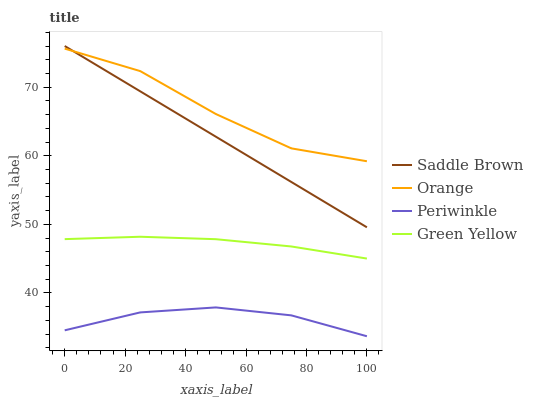Does Periwinkle have the minimum area under the curve?
Answer yes or no. Yes. Does Orange have the maximum area under the curve?
Answer yes or no. Yes. Does Green Yellow have the minimum area under the curve?
Answer yes or no. No. Does Green Yellow have the maximum area under the curve?
Answer yes or no. No. Is Saddle Brown the smoothest?
Answer yes or no. Yes. Is Orange the roughest?
Answer yes or no. Yes. Is Green Yellow the smoothest?
Answer yes or no. No. Is Green Yellow the roughest?
Answer yes or no. No. Does Periwinkle have the lowest value?
Answer yes or no. Yes. Does Green Yellow have the lowest value?
Answer yes or no. No. Does Saddle Brown have the highest value?
Answer yes or no. Yes. Does Green Yellow have the highest value?
Answer yes or no. No. Is Green Yellow less than Orange?
Answer yes or no. Yes. Is Saddle Brown greater than Green Yellow?
Answer yes or no. Yes. Does Orange intersect Saddle Brown?
Answer yes or no. Yes. Is Orange less than Saddle Brown?
Answer yes or no. No. Is Orange greater than Saddle Brown?
Answer yes or no. No. Does Green Yellow intersect Orange?
Answer yes or no. No. 